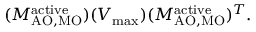Convert formula to latex. <formula><loc_0><loc_0><loc_500><loc_500>( M _ { A O , M O } ^ { a c t i v e } ) ( V _ { \max } ) ( M _ { A O , M O } ^ { a c t i v e } ) ^ { T } .</formula> 